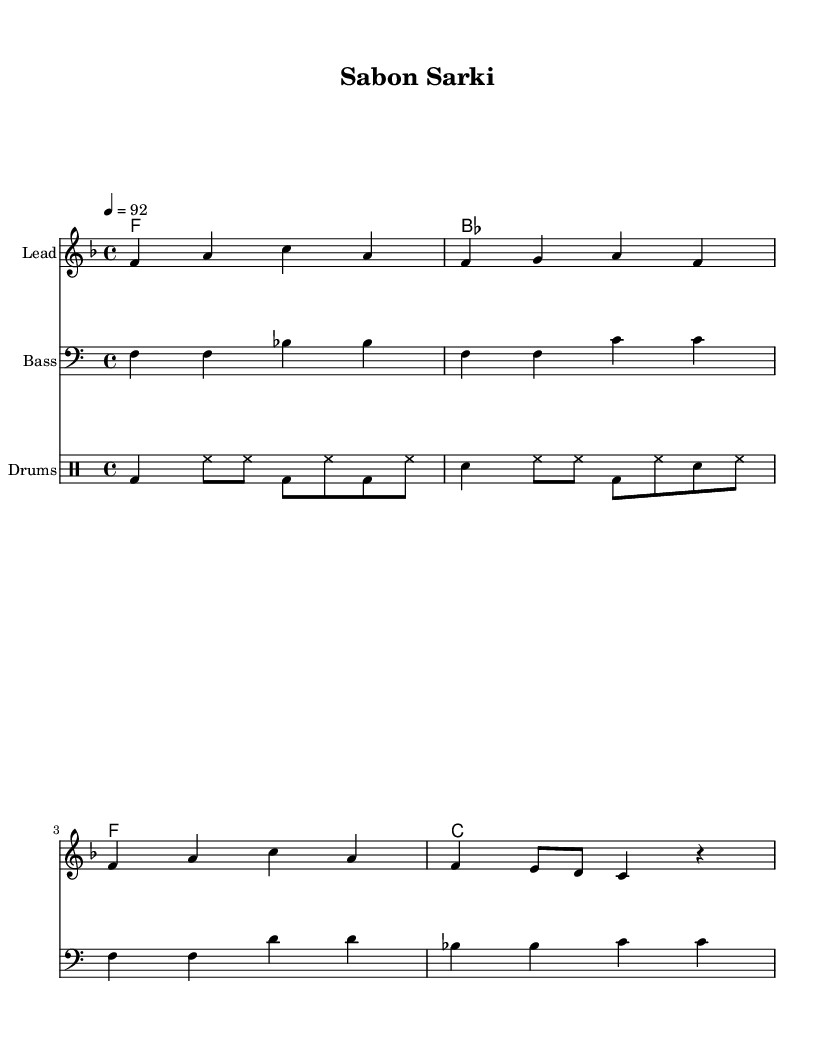What is the key signature of this music? The key signature displayed in the music indicates F major, which has one flat (B flat). This is identified by looking at the key signature placed at the beginning of the staff.
Answer: F major What is the time signature of this music? The time signature shown in the music is 4/4, represented by the two numbers at the beginning of the score. The top number indicates four beats per measure, and the bottom number indicates that a quarter note receives one beat.
Answer: 4/4 What is the tempo marking for this piece? The tempo marking reads "4 = 92," indicating that there are 92 beats in a minute at a quarter note speed. This is found at the beginning of the score, indicating how fast the music should be played.
Answer: 92 How many measures are in the melody? The melody consists of four measures, as seen by the grouping of notes within the vertical bar lines, which are used to separate each measure. Counting the groups shows there are four.
Answer: 4 What type of drum pattern is used in the music? The drum pattern features a combination of bass drums (bd), snare drums (sn), and hi-hats (hh), which are common in hip-hop production. The drum staff clearly indicates varying patterns and syncopation, typical of hip-hop.
Answer: Hip-hop What is the relationship between the melody and the harmony? The melody is supported by the harmony which consists of chord changes. Each chord aligns with the melody notes, creating a musical foundation. The harmony chords provide harmonic support and are listed directly above the melody in the score.
Answer: Chordal support What is the function of the bass line in this piece? The bass line plays a foundational role by providing depth and rhythmic support. It corresponds with the harmony and interacts with the drum loop, adding to the overall groove of the fusion style. The bass notes are positioned to resonate with the chords above them.
Answer: Rhythmic support 